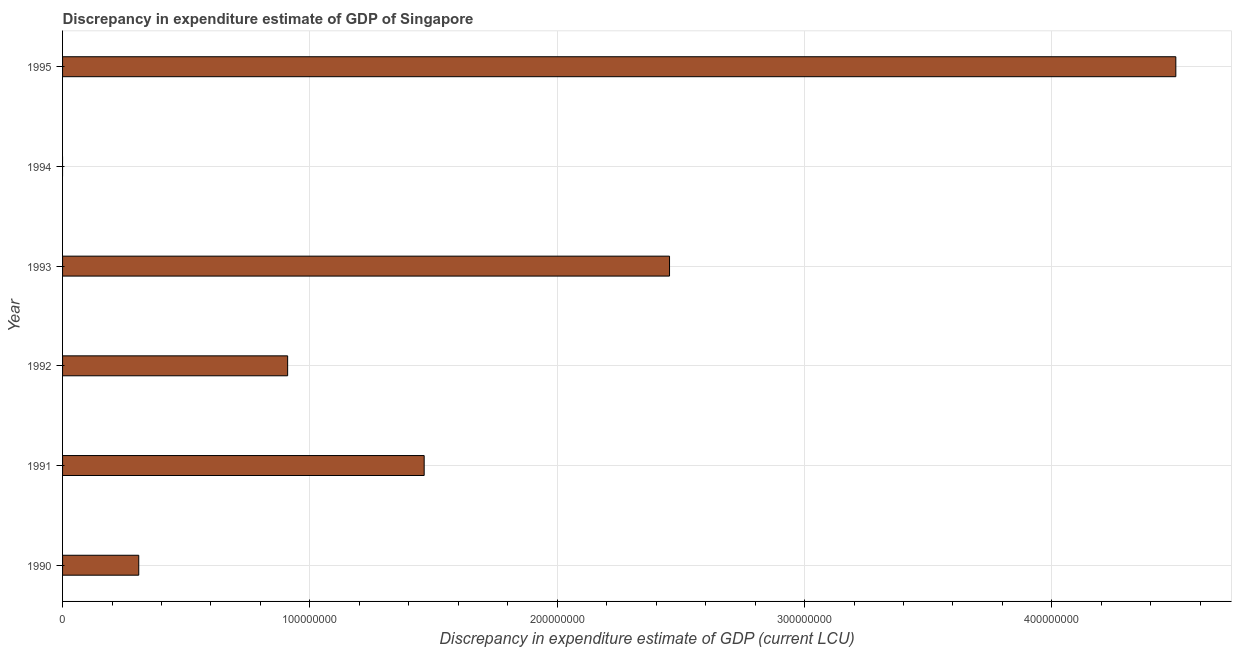Does the graph contain any zero values?
Offer a very short reply. Yes. What is the title of the graph?
Your response must be concise. Discrepancy in expenditure estimate of GDP of Singapore. What is the label or title of the X-axis?
Keep it short and to the point. Discrepancy in expenditure estimate of GDP (current LCU). What is the discrepancy in expenditure estimate of gdp in 1993?
Offer a very short reply. 2.45e+08. Across all years, what is the maximum discrepancy in expenditure estimate of gdp?
Keep it short and to the point. 4.50e+08. What is the sum of the discrepancy in expenditure estimate of gdp?
Offer a terse response. 9.64e+08. What is the difference between the discrepancy in expenditure estimate of gdp in 1991 and 1993?
Offer a terse response. -9.92e+07. What is the average discrepancy in expenditure estimate of gdp per year?
Your response must be concise. 1.61e+08. What is the median discrepancy in expenditure estimate of gdp?
Ensure brevity in your answer.  1.19e+08. In how many years, is the discrepancy in expenditure estimate of gdp greater than 360000000 LCU?
Ensure brevity in your answer.  1. What is the ratio of the discrepancy in expenditure estimate of gdp in 1990 to that in 1993?
Keep it short and to the point. 0.13. What is the difference between the highest and the second highest discrepancy in expenditure estimate of gdp?
Keep it short and to the point. 2.05e+08. Is the sum of the discrepancy in expenditure estimate of gdp in 1990 and 1993 greater than the maximum discrepancy in expenditure estimate of gdp across all years?
Your response must be concise. No. What is the difference between the highest and the lowest discrepancy in expenditure estimate of gdp?
Your answer should be compact. 4.50e+08. How many bars are there?
Provide a short and direct response. 5. What is the Discrepancy in expenditure estimate of GDP (current LCU) of 1990?
Your response must be concise. 3.08e+07. What is the Discrepancy in expenditure estimate of GDP (current LCU) in 1991?
Offer a terse response. 1.46e+08. What is the Discrepancy in expenditure estimate of GDP (current LCU) in 1992?
Keep it short and to the point. 9.10e+07. What is the Discrepancy in expenditure estimate of GDP (current LCU) of 1993?
Your answer should be compact. 2.45e+08. What is the Discrepancy in expenditure estimate of GDP (current LCU) of 1995?
Your response must be concise. 4.50e+08. What is the difference between the Discrepancy in expenditure estimate of GDP (current LCU) in 1990 and 1991?
Provide a succinct answer. -1.15e+08. What is the difference between the Discrepancy in expenditure estimate of GDP (current LCU) in 1990 and 1992?
Make the answer very short. -6.02e+07. What is the difference between the Discrepancy in expenditure estimate of GDP (current LCU) in 1990 and 1993?
Offer a terse response. -2.15e+08. What is the difference between the Discrepancy in expenditure estimate of GDP (current LCU) in 1990 and 1995?
Provide a succinct answer. -4.19e+08. What is the difference between the Discrepancy in expenditure estimate of GDP (current LCU) in 1991 and 1992?
Provide a succinct answer. 5.52e+07. What is the difference between the Discrepancy in expenditure estimate of GDP (current LCU) in 1991 and 1993?
Your response must be concise. -9.92e+07. What is the difference between the Discrepancy in expenditure estimate of GDP (current LCU) in 1991 and 1995?
Offer a very short reply. -3.04e+08. What is the difference between the Discrepancy in expenditure estimate of GDP (current LCU) in 1992 and 1993?
Make the answer very short. -1.54e+08. What is the difference between the Discrepancy in expenditure estimate of GDP (current LCU) in 1992 and 1995?
Provide a short and direct response. -3.59e+08. What is the difference between the Discrepancy in expenditure estimate of GDP (current LCU) in 1993 and 1995?
Give a very brief answer. -2.05e+08. What is the ratio of the Discrepancy in expenditure estimate of GDP (current LCU) in 1990 to that in 1991?
Your answer should be very brief. 0.21. What is the ratio of the Discrepancy in expenditure estimate of GDP (current LCU) in 1990 to that in 1992?
Provide a short and direct response. 0.34. What is the ratio of the Discrepancy in expenditure estimate of GDP (current LCU) in 1990 to that in 1993?
Provide a short and direct response. 0.13. What is the ratio of the Discrepancy in expenditure estimate of GDP (current LCU) in 1990 to that in 1995?
Offer a very short reply. 0.07. What is the ratio of the Discrepancy in expenditure estimate of GDP (current LCU) in 1991 to that in 1992?
Your answer should be compact. 1.61. What is the ratio of the Discrepancy in expenditure estimate of GDP (current LCU) in 1991 to that in 1993?
Provide a short and direct response. 0.6. What is the ratio of the Discrepancy in expenditure estimate of GDP (current LCU) in 1991 to that in 1995?
Provide a succinct answer. 0.33. What is the ratio of the Discrepancy in expenditure estimate of GDP (current LCU) in 1992 to that in 1993?
Make the answer very short. 0.37. What is the ratio of the Discrepancy in expenditure estimate of GDP (current LCU) in 1992 to that in 1995?
Your answer should be compact. 0.2. What is the ratio of the Discrepancy in expenditure estimate of GDP (current LCU) in 1993 to that in 1995?
Your answer should be very brief. 0.55. 